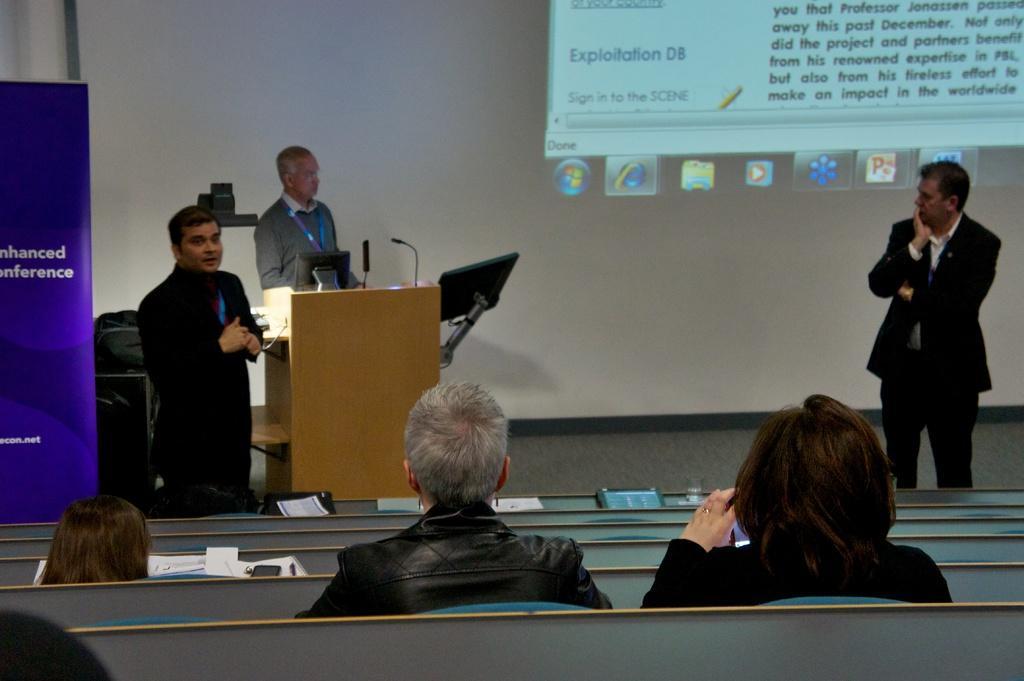In one or two sentences, can you explain what this image depicts? In the picture we can see a stage on it we can see two people are standing near the desk, on it we can see a computer system and a microphone and a man giving speech he is wearing a black color blazer and blue tag and besides them we can see another person standing and watching them, in the front of them we can see some people are sitting on the benches and in the background we can see a wall with a screen and some information on it. 